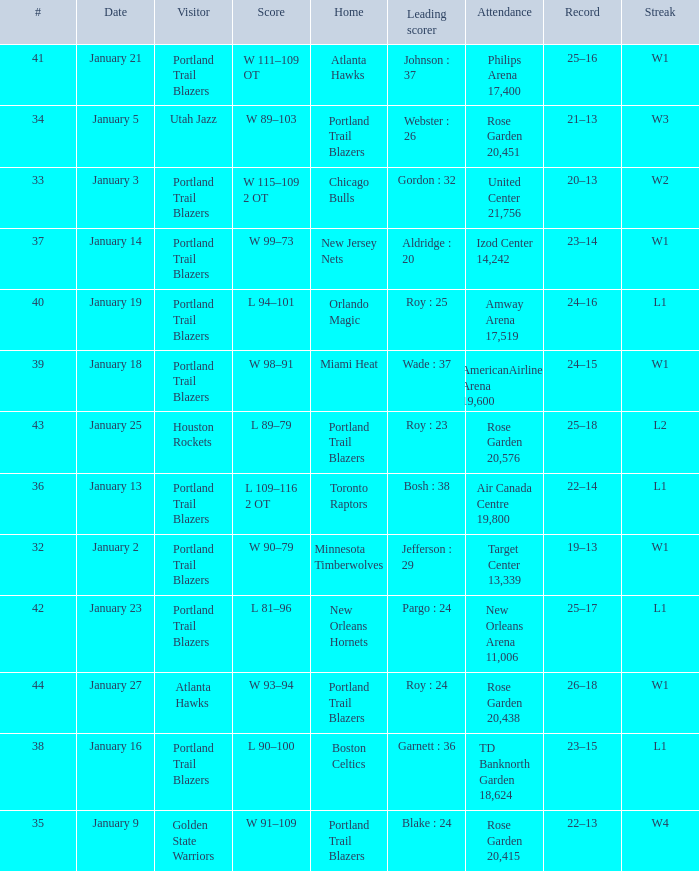Which visitors have a leading scorer of roy : 25 Portland Trail Blazers. 